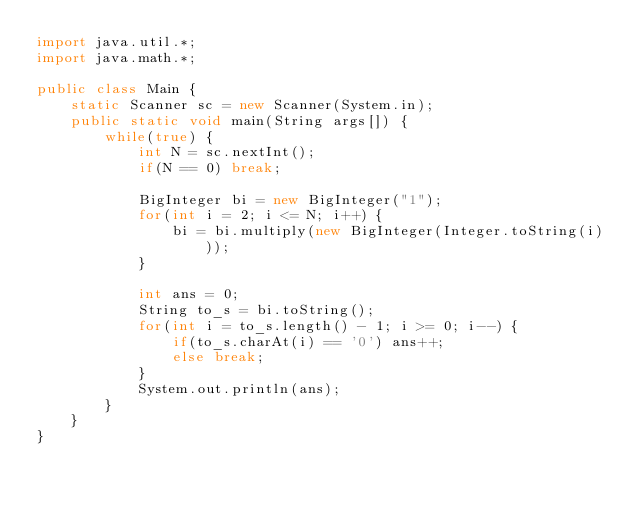<code> <loc_0><loc_0><loc_500><loc_500><_Java_>import java.util.*;
import java.math.*;

public class Main {
	static Scanner sc = new Scanner(System.in);
	public static void main(String args[]) {
		while(true) {
			int N = sc.nextInt();
			if(N == 0) break;

			BigInteger bi = new BigInteger("1");
			for(int i = 2; i <= N; i++) {
				bi = bi.multiply(new BigInteger(Integer.toString(i)));
			}

			int ans = 0;
			String to_s = bi.toString();
			for(int i = to_s.length() - 1; i >= 0; i--) {
				if(to_s.charAt(i) == '0') ans++;
				else break;
			}
			System.out.println(ans);
		}
	}
}</code> 